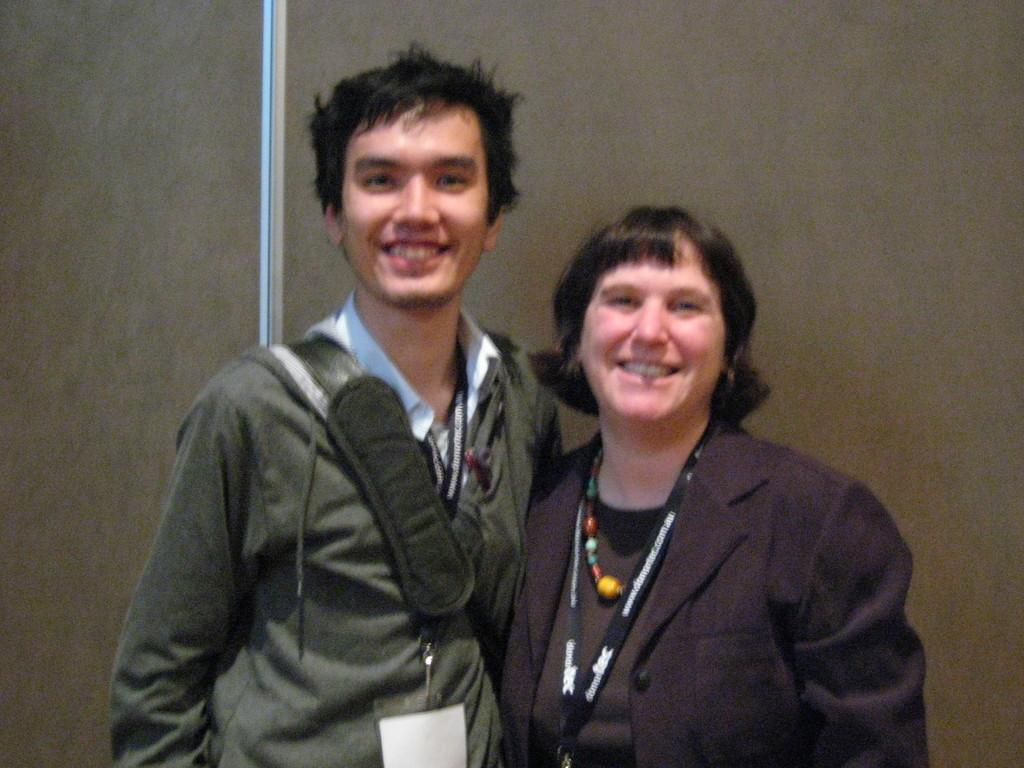Who are the people in the foreground of the picture? There is a man and a woman in the foreground of the picture. What are the man and woman doing in the image? The man and woman are standing in the image. What can be seen in the background of the picture? There is a wall in the background of the picture. What type of bone can be seen in the picture? There is no bone present in the picture; it features a man and a woman standing in the foreground. What emotion is the cub expressing in the picture? There is no cub present in the picture, so it is not possible to determine any emotions being expressed. 